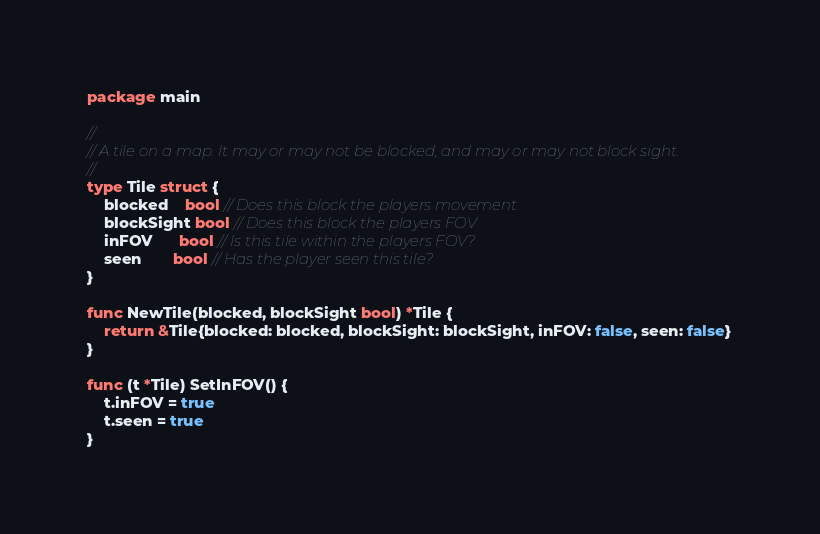<code> <loc_0><loc_0><loc_500><loc_500><_Go_>package main

//
// A tile on a map. It may or may not be blocked, and may or may not block sight.
//
type Tile struct {
	blocked    bool // Does this block the players movement
	blockSight bool // Does this block the players FOV
	inFOV      bool // Is this tile within the players FOV?
	seen       bool // Has the player seen this tile?
}

func NewTile(blocked, blockSight bool) *Tile {
	return &Tile{blocked: blocked, blockSight: blockSight, inFOV: false, seen: false}
}

func (t *Tile) SetInFOV() {
	t.inFOV = true
	t.seen = true
}
</code> 